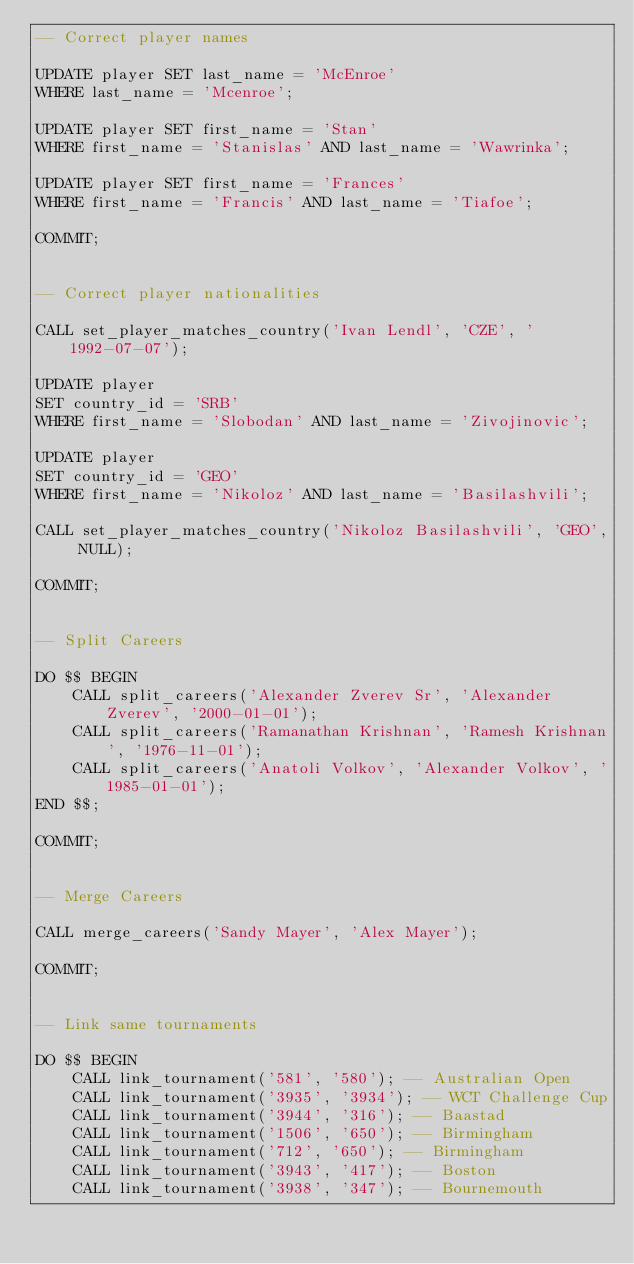Convert code to text. <code><loc_0><loc_0><loc_500><loc_500><_SQL_>-- Correct player names

UPDATE player SET last_name = 'McEnroe'
WHERE last_name = 'Mcenroe';

UPDATE player SET first_name = 'Stan'
WHERE first_name = 'Stanislas' AND last_name = 'Wawrinka';

UPDATE player SET first_name = 'Frances'
WHERE first_name = 'Francis' AND last_name = 'Tiafoe';

COMMIT;


-- Correct player nationalities

CALL set_player_matches_country('Ivan Lendl', 'CZE', '1992-07-07');

UPDATE player
SET country_id = 'SRB'
WHERE first_name = 'Slobodan' AND last_name = 'Zivojinovic';

UPDATE player
SET country_id = 'GEO'
WHERE first_name = 'Nikoloz' AND last_name = 'Basilashvili';

CALL set_player_matches_country('Nikoloz Basilashvili', 'GEO', NULL);

COMMIT;


-- Split Careers

DO $$ BEGIN
    CALL split_careers('Alexander Zverev Sr', 'Alexander Zverev', '2000-01-01');
    CALL split_careers('Ramanathan Krishnan', 'Ramesh Krishnan', '1976-11-01');
    CALL split_careers('Anatoli Volkov', 'Alexander Volkov', '1985-01-01');
END $$;

COMMIT;


-- Merge Careers

CALL merge_careers('Sandy Mayer', 'Alex Mayer');

COMMIT;


-- Link same tournaments

DO $$ BEGIN
    CALL link_tournament('581', '580'); -- Australian Open
    CALL link_tournament('3935', '3934'); -- WCT Challenge Cup
    CALL link_tournament('3944', '316'); -- Baastad
    CALL link_tournament('1506', '650'); -- Birmingham
    CALL link_tournament('712', '650'); -- Birmingham
    CALL link_tournament('3943', '417'); -- Boston
    CALL link_tournament('3938', '347'); -- Bournemouth</code> 